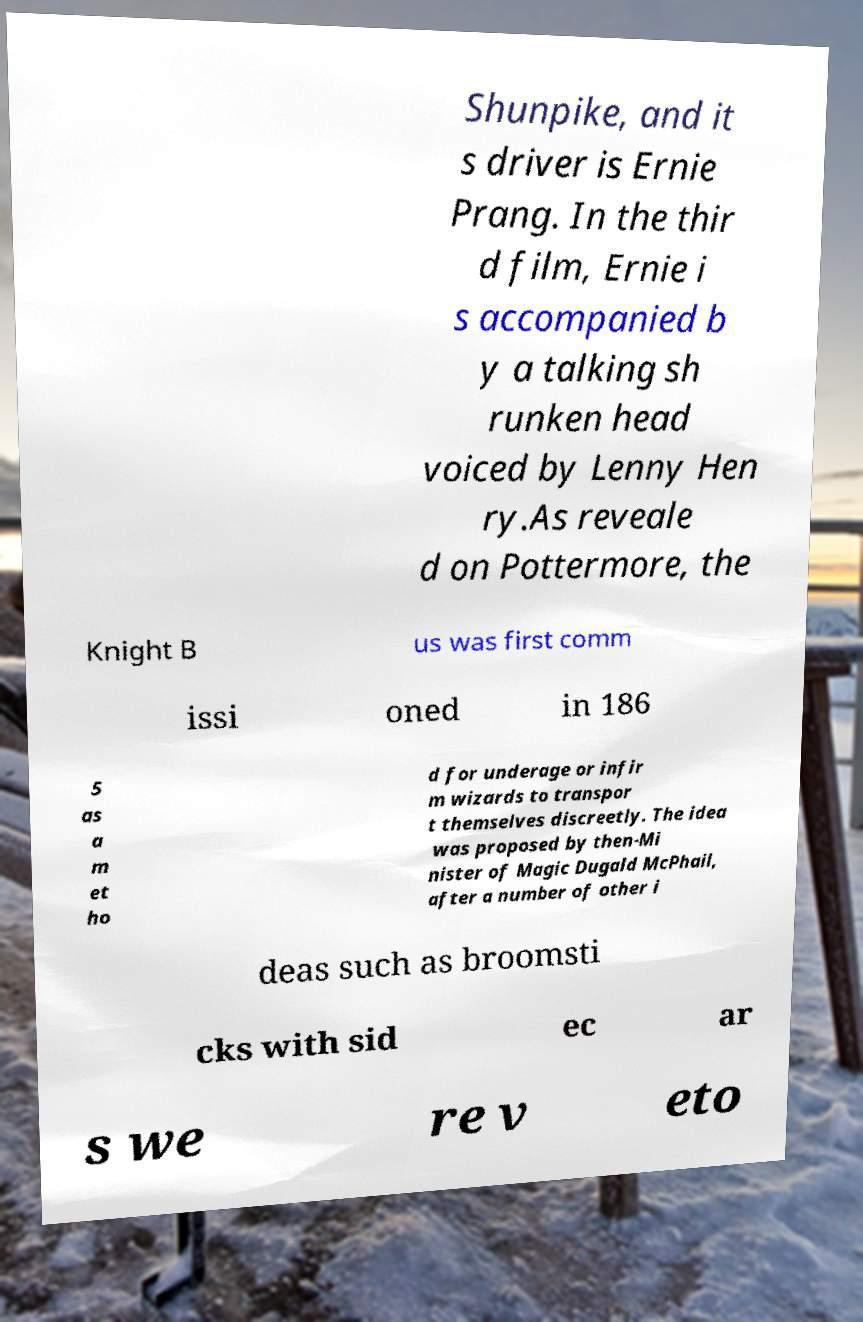There's text embedded in this image that I need extracted. Can you transcribe it verbatim? Shunpike, and it s driver is Ernie Prang. In the thir d film, Ernie i s accompanied b y a talking sh runken head voiced by Lenny Hen ry.As reveale d on Pottermore, the Knight B us was first comm issi oned in 186 5 as a m et ho d for underage or infir m wizards to transpor t themselves discreetly. The idea was proposed by then-Mi nister of Magic Dugald McPhail, after a number of other i deas such as broomsti cks with sid ec ar s we re v eto 